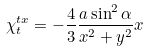<formula> <loc_0><loc_0><loc_500><loc_500>\chi _ { t } ^ { t x } = - \frac { 4 } { 3 } \frac { a \sin ^ { 2 } \alpha } { x ^ { 2 } + y ^ { 2 } } x</formula> 